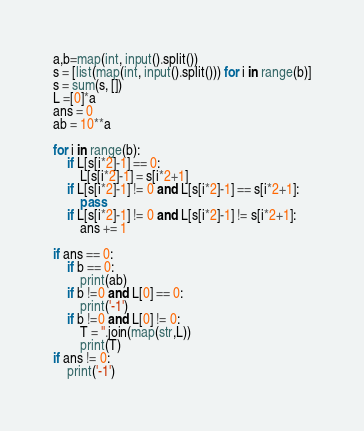<code> <loc_0><loc_0><loc_500><loc_500><_Python_>a,b=map(int, input().split())
s = [list(map(int, input().split())) for i in range(b)]
s = sum(s, [])
L =[0]*a
ans = 0
ab = 10**a

for i in range(b):
    if L[s[i*2]-1] == 0:
        L[s[i*2]-1] = s[i*2+1]
    if L[s[i*2]-1] != 0 and L[s[i*2]-1] == s[i*2+1]:
        pass
    if L[s[i*2]-1] != 0 and L[s[i*2]-1] != s[i*2+1]:
        ans += 1

if ans == 0:
    if b == 0:
        print(ab)
    if b !=0 and L[0] == 0:
        print('-1')
    if b !=0 and L[0] != 0:
        T = ''.join(map(str,L))
        print(T)
if ans != 0:
    print('-1')</code> 